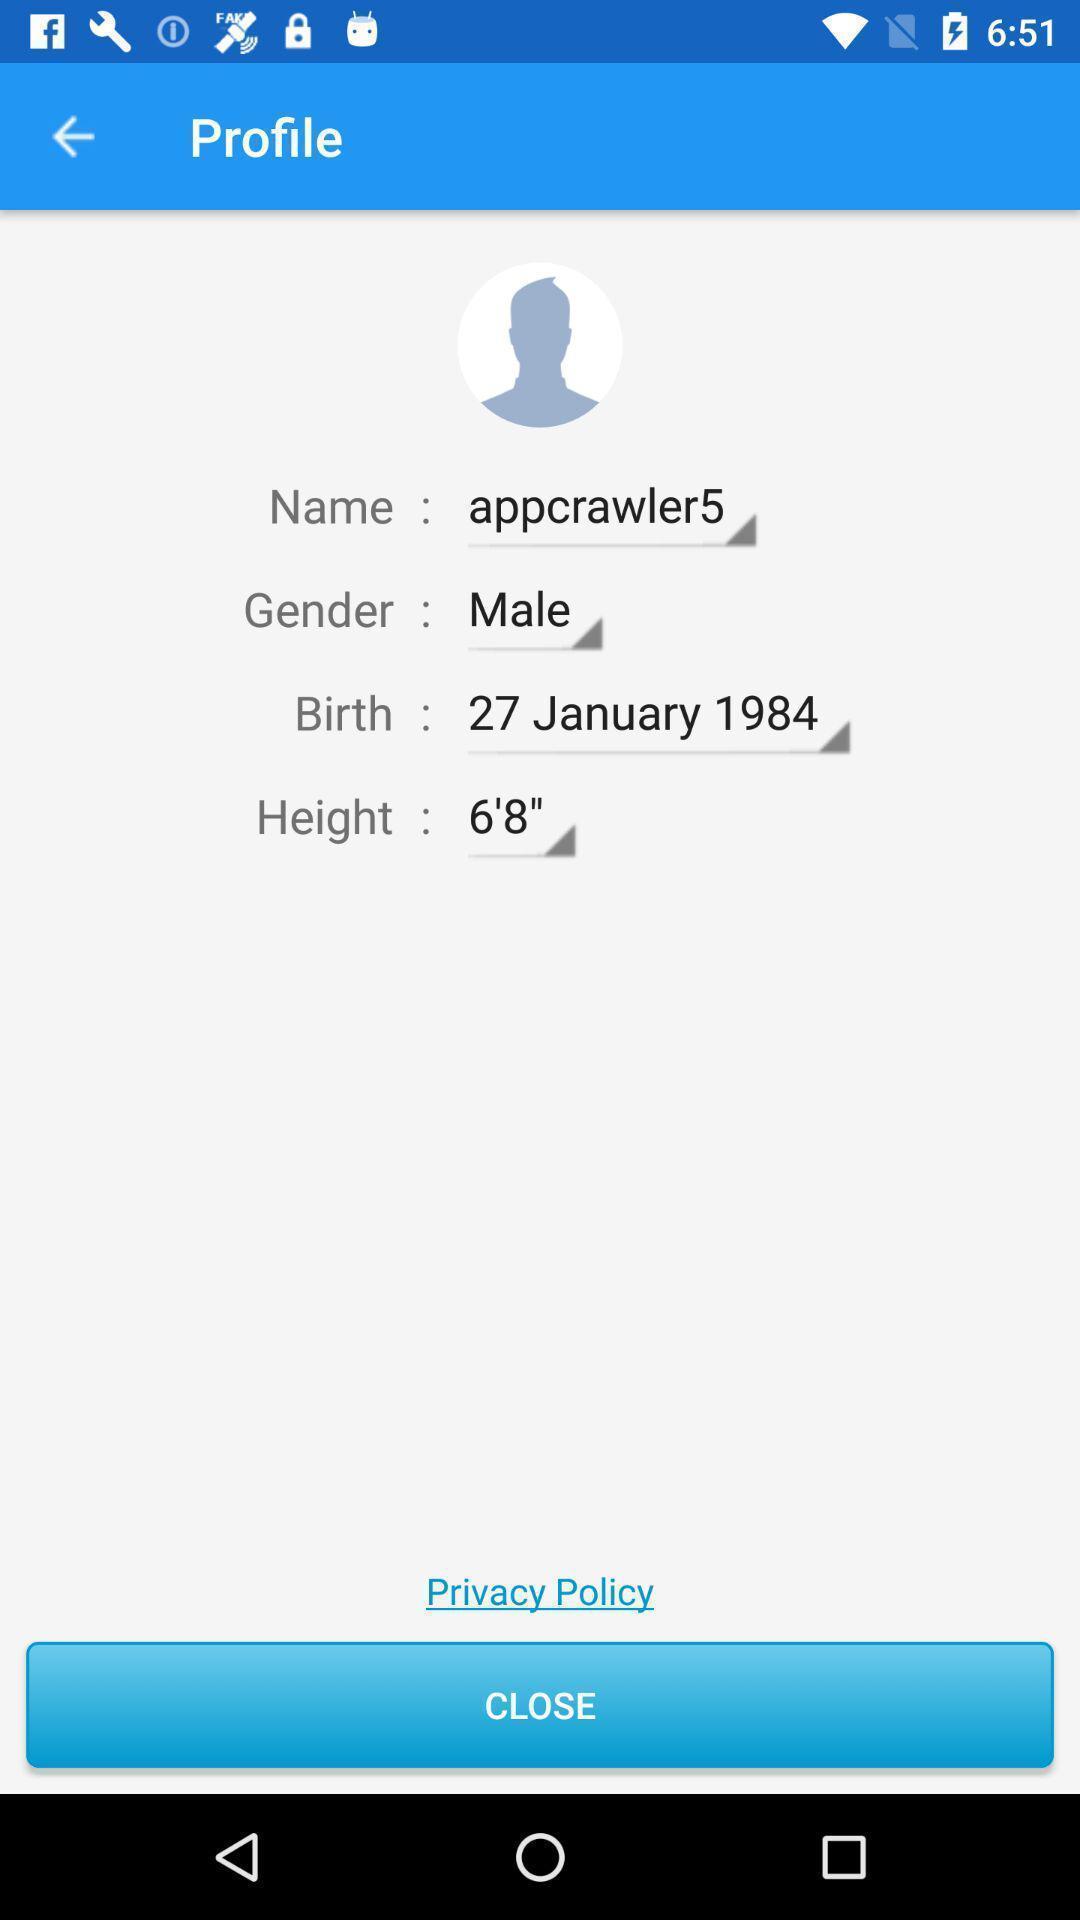Tell me about the visual elements in this screen capture. Screen shows about a profile. 